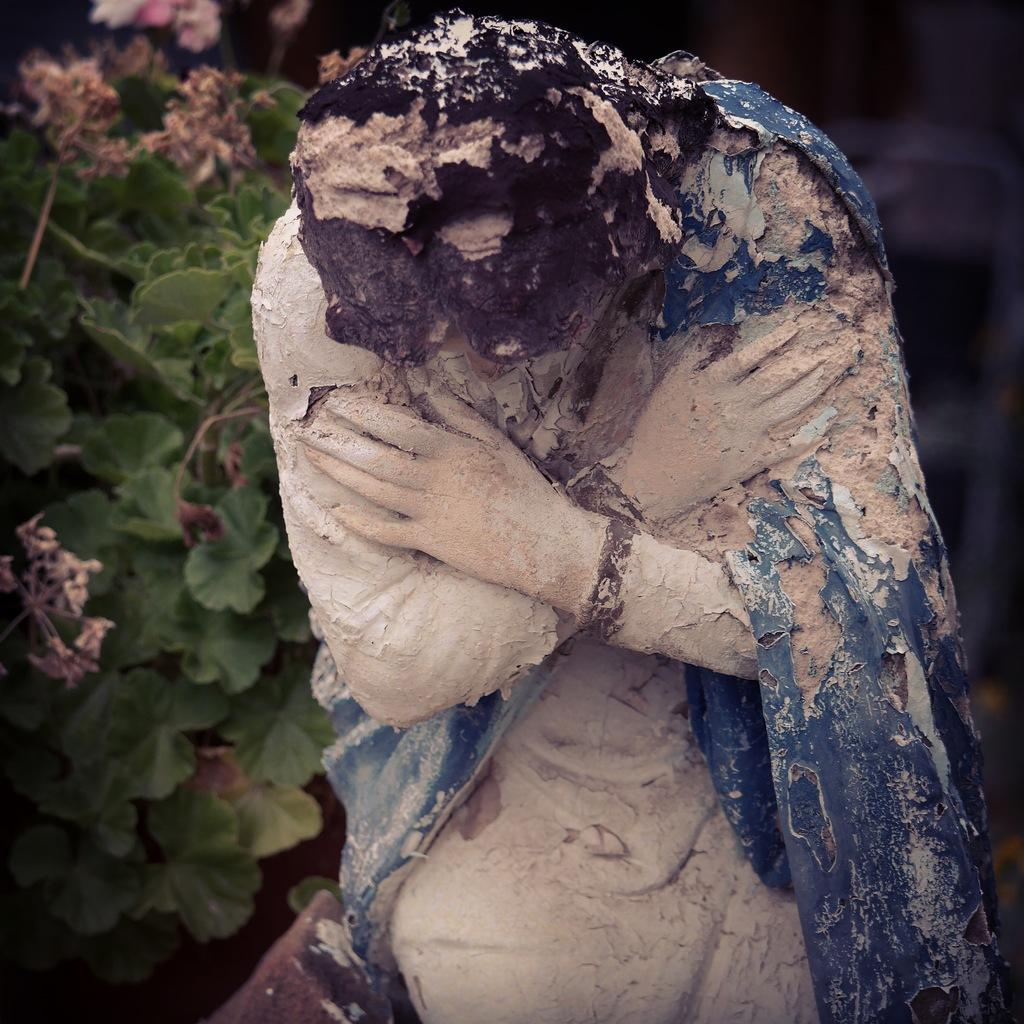What is the main subject of the picture? The main subject of the picture is a sculpture. Can you describe the background of the picture? There is a plant with leaves in the background of the picture. What language is being spoken by the sculpture in the image? The sculpture is not capable of speaking a language, as it is an inanimate object. 